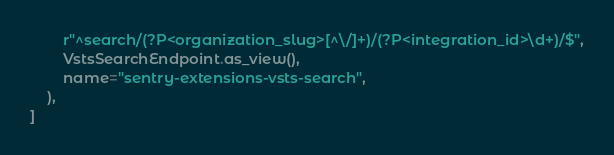<code> <loc_0><loc_0><loc_500><loc_500><_Python_>        r"^search/(?P<organization_slug>[^\/]+)/(?P<integration_id>\d+)/$",
        VstsSearchEndpoint.as_view(),
        name="sentry-extensions-vsts-search",
    ),
]
</code> 